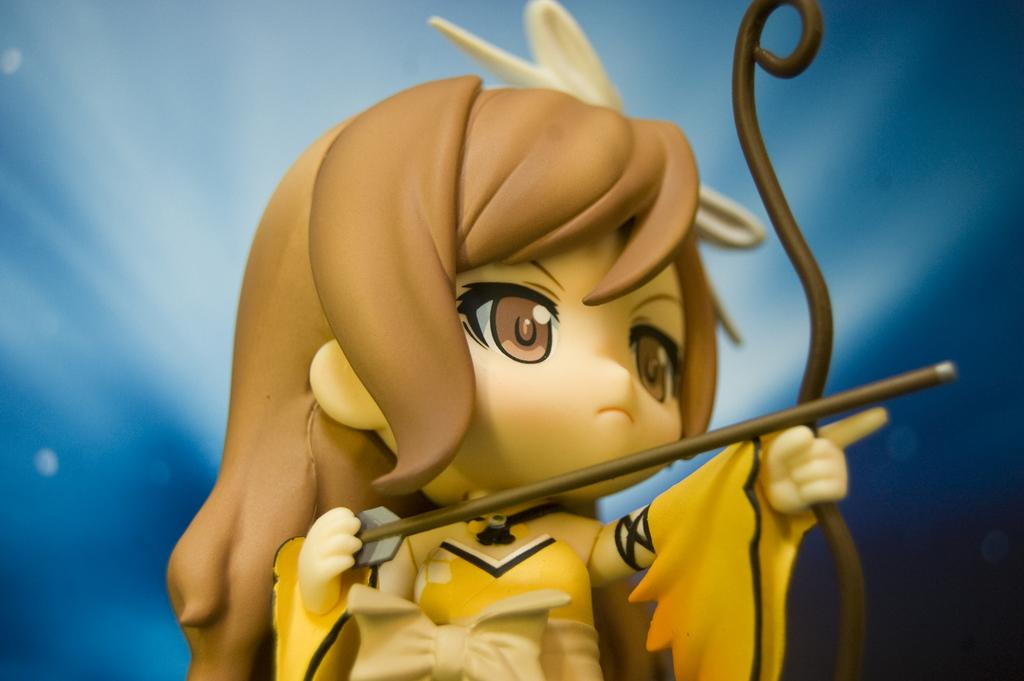What type of object is the main subject in the image? There is an animated toy in the image. What is the toy holding in its hands? The toy is holding a bow and arrow. What colors are used in the toy's dress? The toy is wearing a yellow and cream color dress. What color is the background of the image? The background of the image is blue. What type of kettle is being used to play volleyball in the image? There is no kettle or volleyball present in the image; it features an animated toy holding a bow and arrow. Is there a fight happening between the toy and another character in the image? There is no fight depicted in the image; the toy is simply holding a bow and arrow. 